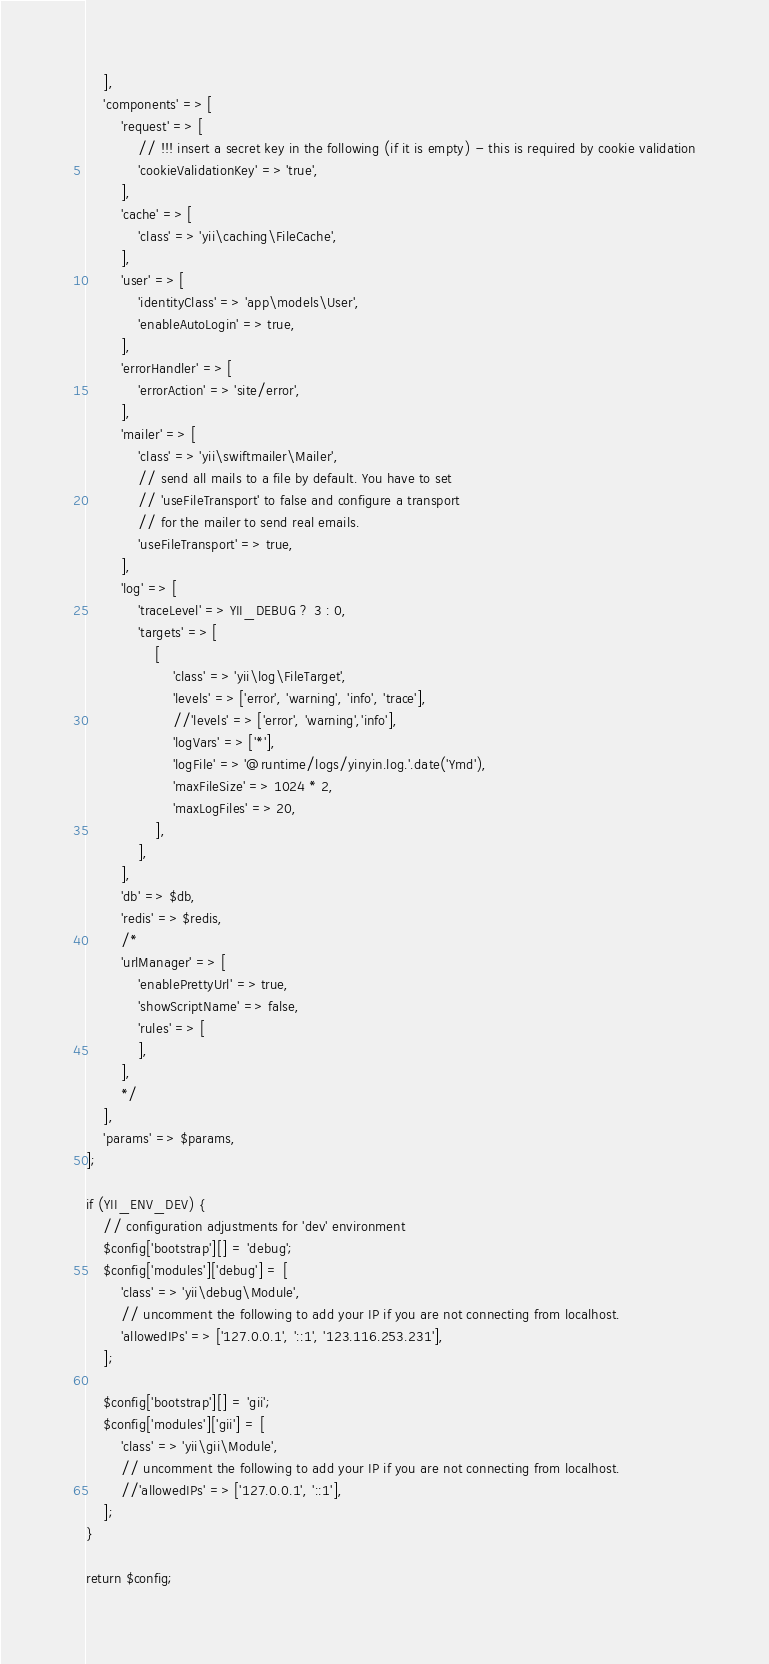<code> <loc_0><loc_0><loc_500><loc_500><_PHP_>    ],
    'components' => [
        'request' => [
            // !!! insert a secret key in the following (if it is empty) - this is required by cookie validation
            'cookieValidationKey' => 'true',
        ],
        'cache' => [
            'class' => 'yii\caching\FileCache',
        ],
        'user' => [
            'identityClass' => 'app\models\User',
            'enableAutoLogin' => true,
        ],
        'errorHandler' => [
            'errorAction' => 'site/error',
        ],
        'mailer' => [
            'class' => 'yii\swiftmailer\Mailer',
            // send all mails to a file by default. You have to set
            // 'useFileTransport' to false and configure a transport
            // for the mailer to send real emails.
            'useFileTransport' => true,
        ],
        'log' => [
            'traceLevel' => YII_DEBUG ? 3 : 0,
            'targets' => [
                [
                    'class' => 'yii\log\FileTarget',
                    'levels' => ['error', 'warning', 'info', 'trace'],
                    //'levels' => ['error', 'warning','info'],
                    'logVars' => ['*'],
                    'logFile' => '@runtime/logs/yinyin.log.'.date('Ymd'),
                    'maxFileSize' => 1024 * 2,
                    'maxLogFiles' => 20,
                ],
            ],
        ],
        'db' => $db,
        'redis' => $redis,
        /*
        'urlManager' => [
            'enablePrettyUrl' => true,
            'showScriptName' => false,
            'rules' => [
            ],
        ],
        */
    ],
    'params' => $params,
];

if (YII_ENV_DEV) {
    // configuration adjustments for 'dev' environment
    $config['bootstrap'][] = 'debug';
    $config['modules']['debug'] = [
        'class' => 'yii\debug\Module',
        // uncomment the following to add your IP if you are not connecting from localhost.
        'allowedIPs' => ['127.0.0.1', '::1', '123.116.253.231'],
    ];

    $config['bootstrap'][] = 'gii';
    $config['modules']['gii'] = [
        'class' => 'yii\gii\Module',
        // uncomment the following to add your IP if you are not connecting from localhost.
        //'allowedIPs' => ['127.0.0.1', '::1'],
    ];
}

return $config;
</code> 